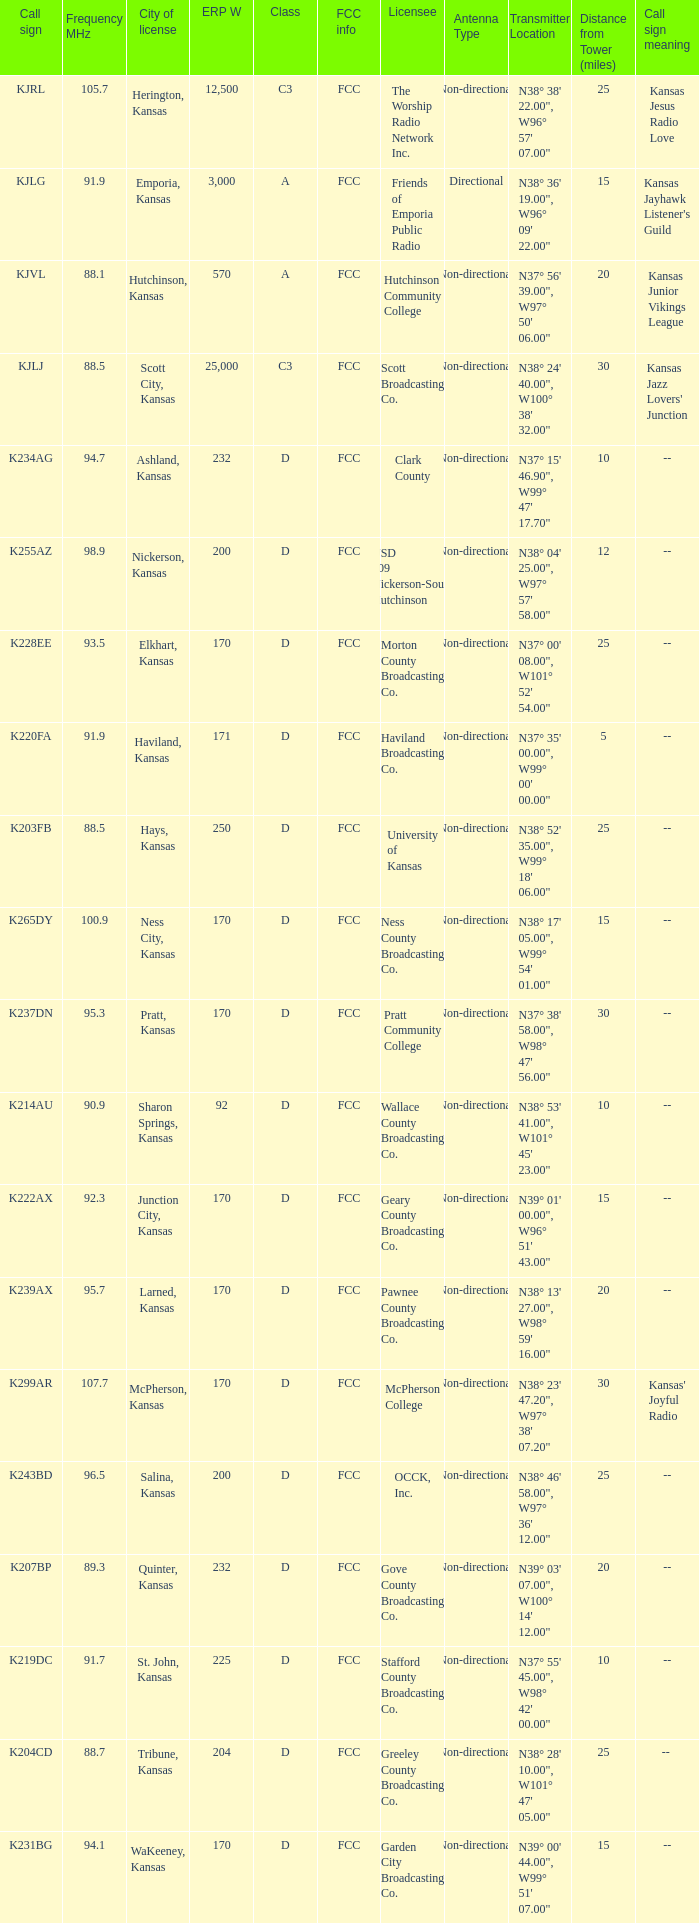Call sign of k231bg has what sum of erp w? 170.0. 